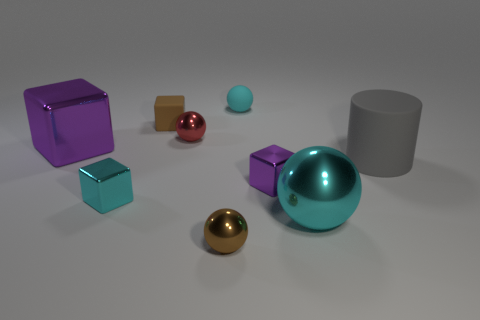There is a tiny purple object that is the same shape as the tiny cyan shiny thing; what is its material?
Provide a short and direct response. Metal. What number of shiny spheres are to the right of the red object and behind the small brown ball?
Provide a succinct answer. 1. What is the shape of the cyan rubber object?
Your answer should be very brief. Sphere. How many other things are there of the same material as the cyan cube?
Ensure brevity in your answer.  5. What color is the metallic ball that is left of the tiny shiny ball that is in front of the cyan cube that is to the left of the cyan matte sphere?
Provide a succinct answer. Red. What material is the brown ball that is the same size as the brown rubber cube?
Offer a very short reply. Metal. How many objects are either small balls that are behind the small purple block or big purple things?
Provide a succinct answer. 3. Is there a large gray matte ball?
Your answer should be very brief. No. What material is the brown object in front of the large rubber cylinder?
Keep it short and to the point. Metal. What material is the object that is the same color as the small matte cube?
Ensure brevity in your answer.  Metal. 